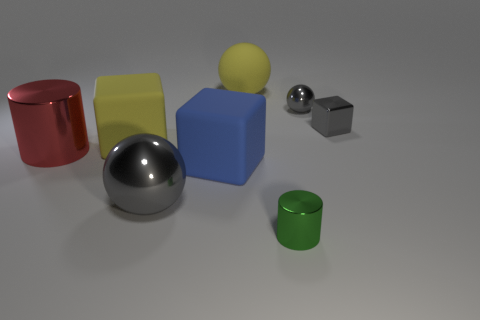There is another sphere that is the same color as the big metal ball; what size is it?
Make the answer very short. Small. Is the large cube behind the blue matte block made of the same material as the big cube in front of the big red metal thing?
Offer a very short reply. Yes. There is a gray metallic thing left of the tiny green metal cylinder; what is its shape?
Make the answer very short. Sphere. Is the number of large blue cubes less than the number of large cubes?
Provide a succinct answer. Yes. Is there a gray object on the left side of the metal sphere that is to the right of the big metal thing that is in front of the red shiny cylinder?
Ensure brevity in your answer.  Yes. How many rubber objects are large red cylinders or large blue objects?
Your response must be concise. 1. Is the color of the big metal cylinder the same as the small shiny sphere?
Offer a very short reply. No. How many green metal cylinders are in front of the large blue cube?
Offer a very short reply. 1. What number of cylinders are both behind the small green cylinder and on the right side of the big red thing?
Your answer should be compact. 0. What is the shape of the green thing that is made of the same material as the tiny cube?
Your answer should be compact. Cylinder. 